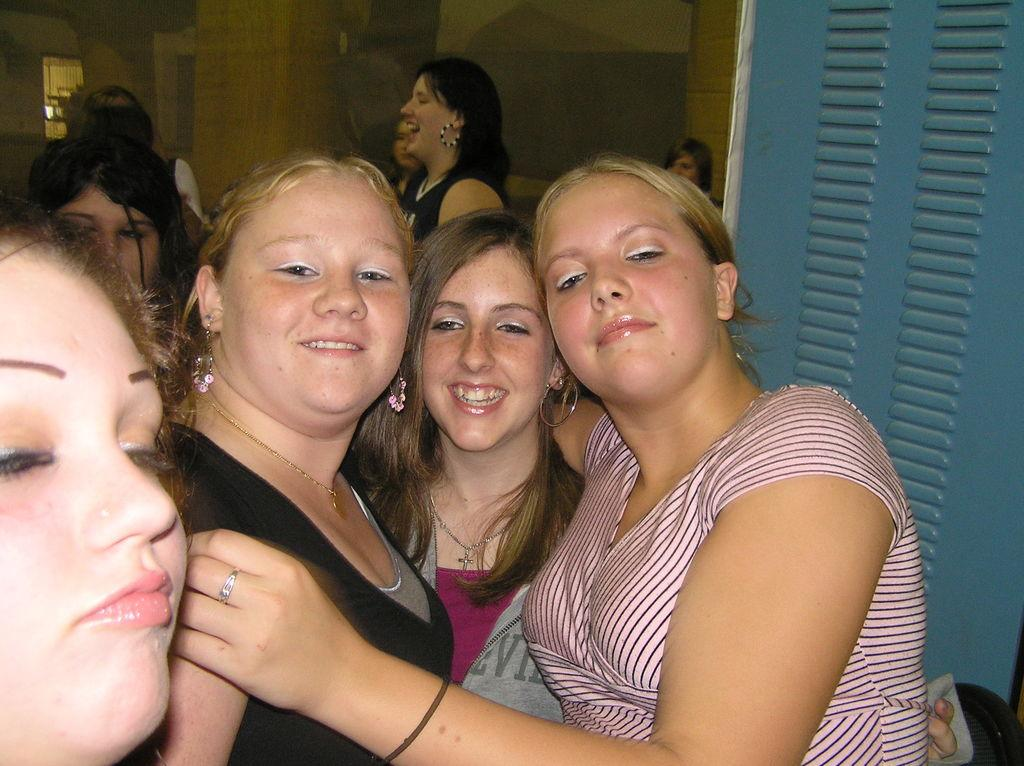What is the main subject of the image? The main subject of the image is a crowd. Where is the crowd located in the image? The crowd is on the floor. What can be seen in the background of the image? There is a wall, a window, and a curtain associated with the window in the background. In which setting is the image taken? The image is taken in a room. What type of stove can be seen in the image? There is no stove present in the image. How does the crowd move in the image? The crowd is not moving in the image; it is stationary on the floor. 